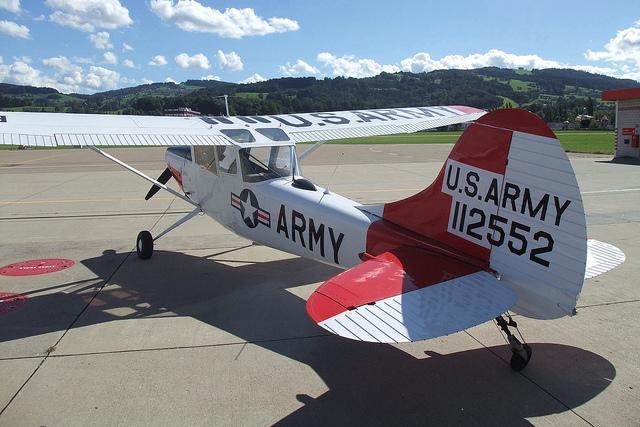How many yellow boats are there?
Give a very brief answer. 0. 